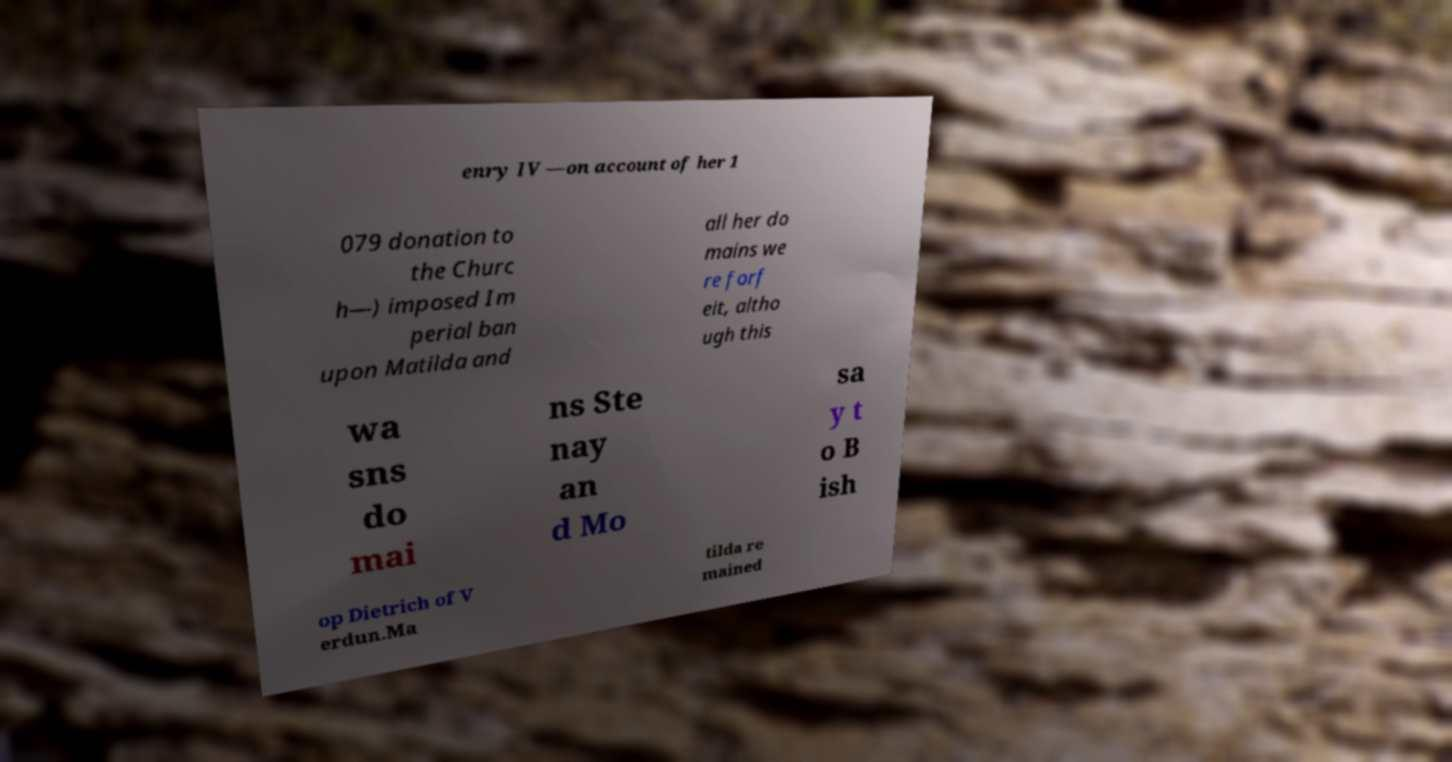Please read and relay the text visible in this image. What does it say? enry IV —on account of her 1 079 donation to the Churc h—) imposed Im perial ban upon Matilda and all her do mains we re forf eit, altho ugh this wa sns do mai ns Ste nay an d Mo sa y t o B ish op Dietrich of V erdun.Ma tilda re mained 